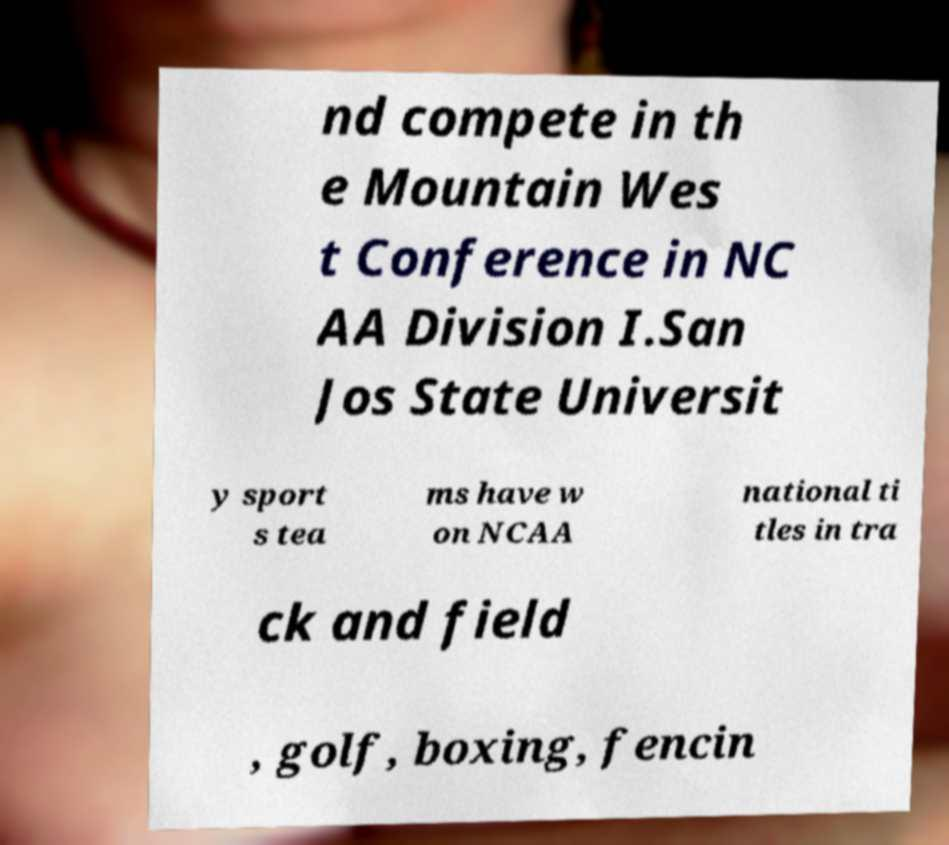Could you extract and type out the text from this image? nd compete in th e Mountain Wes t Conference in NC AA Division I.San Jos State Universit y sport s tea ms have w on NCAA national ti tles in tra ck and field , golf, boxing, fencin 